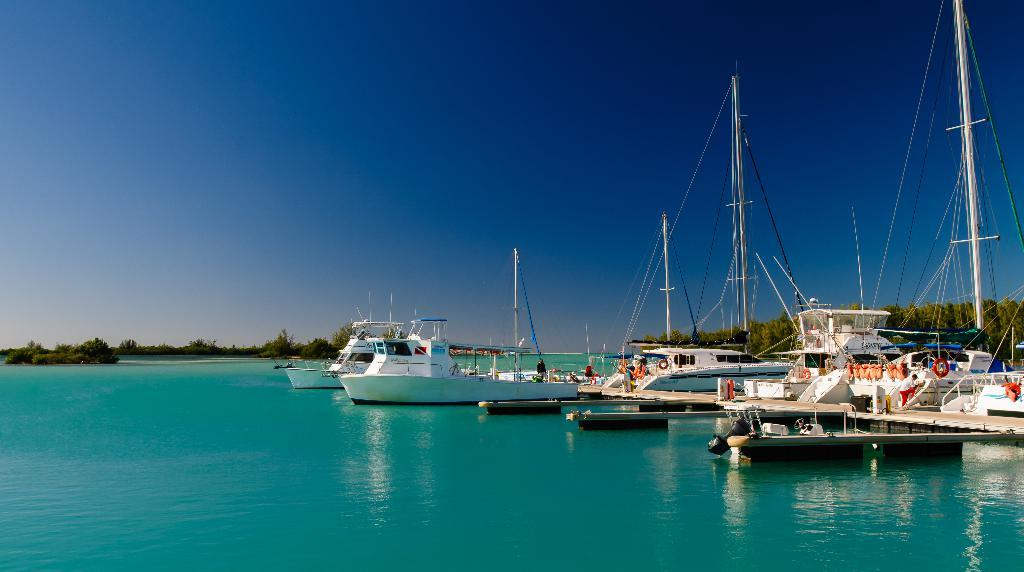What type of vehicles can be seen in the water in the image? There are boats in the water in the image. What structure is present in the image besides the boats? There is a wooden platform in the image. What type of natural vegetation is visible in the image? There are trees in the image. What part of the natural environment is visible in the image? The sky is visible in the image. Can you describe the person in the image? There is a person standing in the image. What is the opinion of the cannon about the boats in the image? There is no cannon present in the image, so it cannot have an opinion about the boats. How does the tank interact with the wooden platform in the image? There is no tank present in the image, so it cannot interact with the wooden platform. 